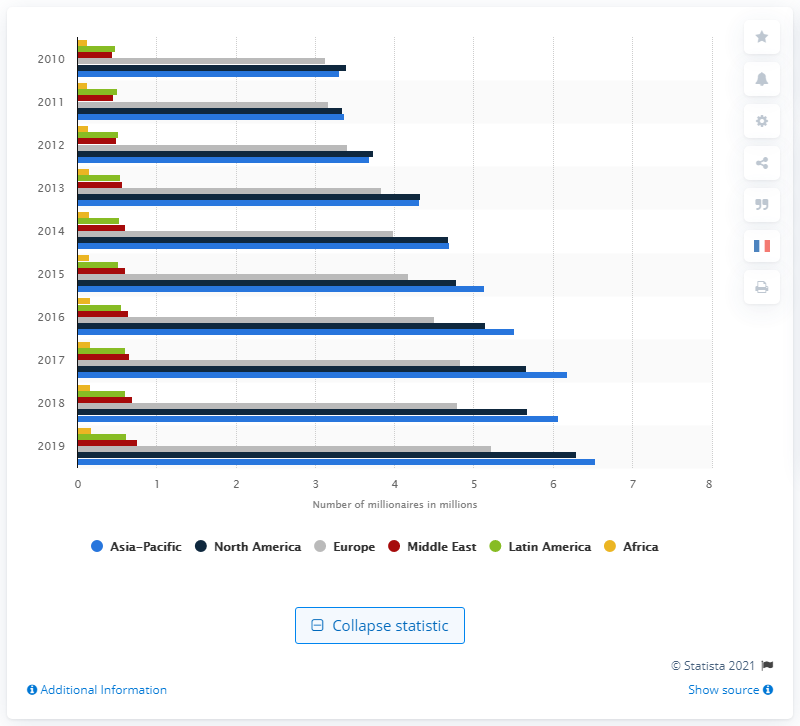What was the number of millionaires in the Asia Pacific region in 2019? In 2019, the Asia Pacific region was home to approximately 6.53 million millionaires. This figure emphasizes the region's significant economic growth and its increasing share of global wealth. 